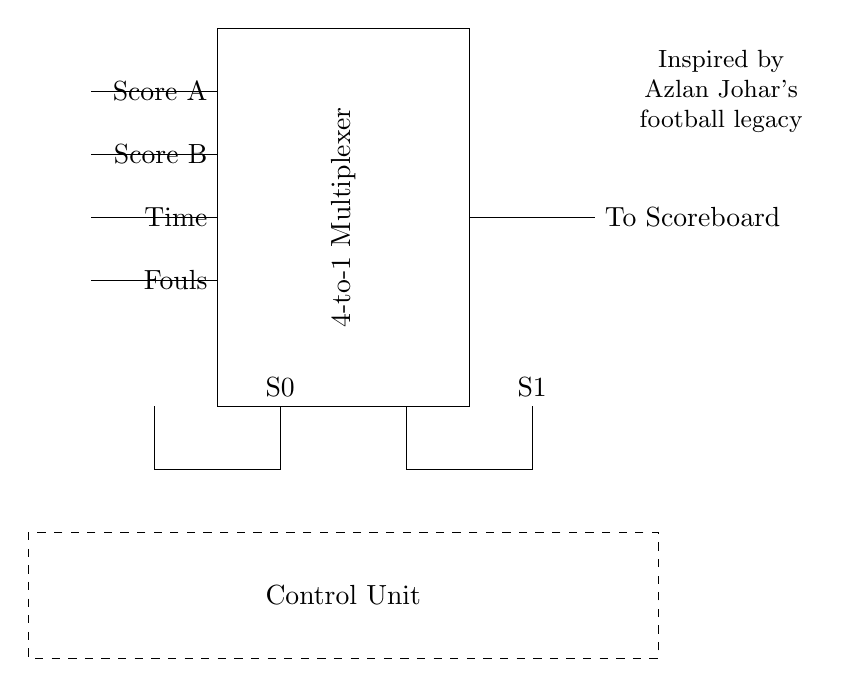What is the function of the multiplexer in this circuit? The multiplexer selects one of the four input signals (scores, time, fouls) based on the select lines and sends it to the scoreboard.
Answer: Select one input What are the input lines connected to the multiplexer? The input lines are connected to Score A, Score B, Time, and Fouls, providing the data the multiplexer will select from.
Answer: Score A, Score B, Time, Fouls How many select lines are present in this circuit? There are two select lines, S0 and S1, used to choose which input to output to the scoreboard.
Answer: Two Which component is represented as a dashed rectangle? The dashed rectangle represents the control unit, which likely manages the selection of inputs for the multiplexer.
Answer: Control Unit What does the circuit output to the scoreboard? The circuit outputs the selected input data to the scoreboard, allowing for dynamic display changes.
Answer: To Scoreboard What is the significance of the text near the multiplexer? The text pays tribute to Azlan Johar's football legacy, indicating an inspiration or homage connected to this design.
Answer: Inspired by Azlan Johar's football legacy 